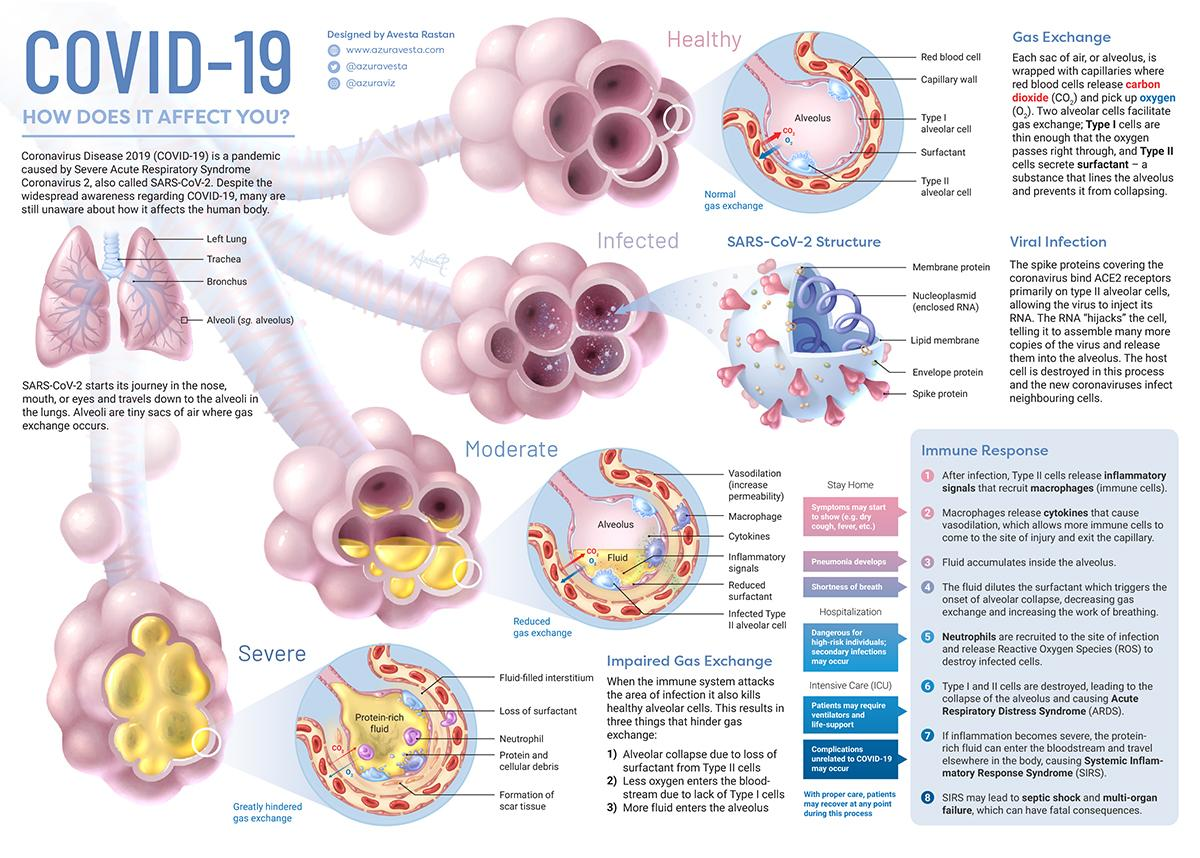Draw attention to some important aspects in this diagram. The blue spiral tube in the SARS-CoV-2 structure is known as the nucleoplasmid, which encloses a strand of RNA. The full form of SARS is Severe Acute Respiratory Syndrome. Severe infection is characterized by the presence of a yellow fluid that fully occupies the alveoli, which is rich in protein. Hospitalization may be required at the stage of the immune response known as severe sepsis. The normal gas exchange diagram shows two gases, carbon dioxide (CO2) and oxygen (O2), which are involved in the process of gas exchange between organisms and their environment. 